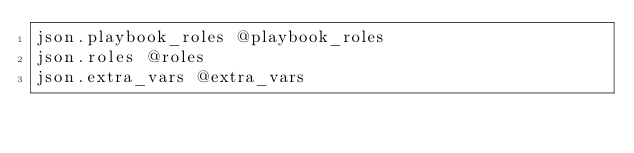Convert code to text. <code><loc_0><loc_0><loc_500><loc_500><_Ruby_>json.playbook_roles @playbook_roles
json.roles @roles
json.extra_vars @extra_vars
</code> 